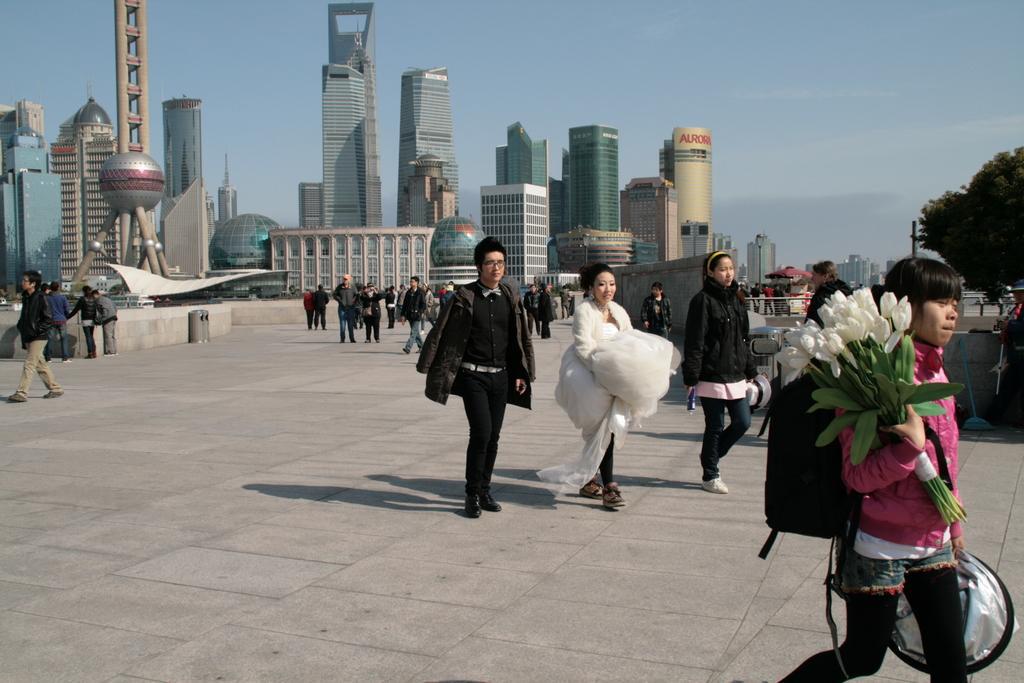Describe this image in one or two sentences. In this image we can see some buildings, two dustbins near to the wall, some people are standing, one pole, one big tree, some people are walking, one building wall there is some text, some people are holding some objects, some objects are on the surface, one person wearing backpack and holding white flowers Bokeh. At the top there is the sky. 